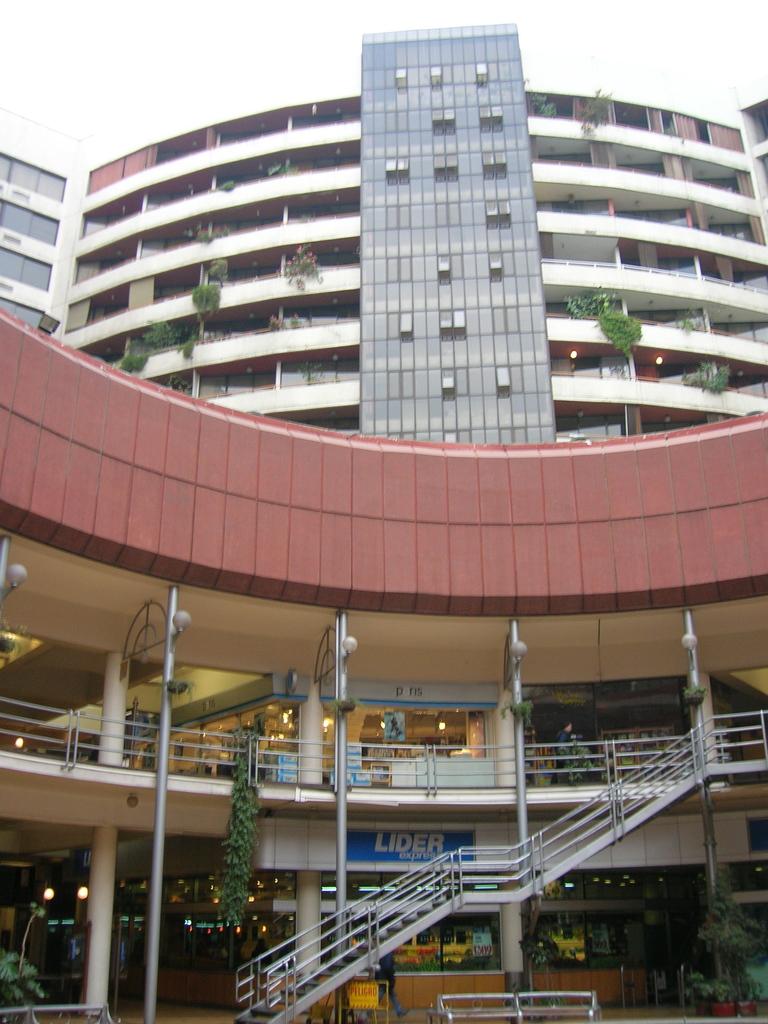What does the banner say?
Your response must be concise. Lider. 